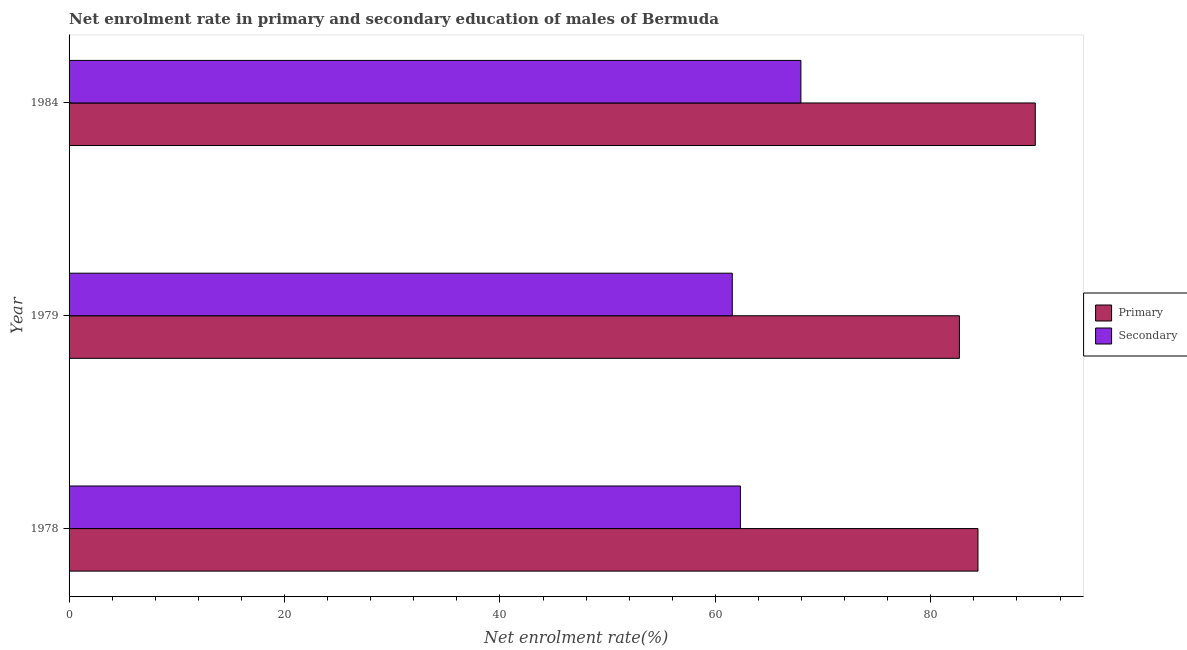How many different coloured bars are there?
Your answer should be compact. 2. Are the number of bars per tick equal to the number of legend labels?
Your answer should be very brief. Yes. How many bars are there on the 1st tick from the bottom?
Your answer should be compact. 2. What is the label of the 2nd group of bars from the top?
Provide a succinct answer. 1979. In how many cases, is the number of bars for a given year not equal to the number of legend labels?
Your answer should be very brief. 0. What is the enrollment rate in secondary education in 1984?
Your response must be concise. 67.95. Across all years, what is the maximum enrollment rate in primary education?
Give a very brief answer. 89.7. Across all years, what is the minimum enrollment rate in secondary education?
Keep it short and to the point. 61.57. In which year was the enrollment rate in primary education minimum?
Give a very brief answer. 1979. What is the total enrollment rate in primary education in the graph?
Offer a very short reply. 256.75. What is the difference between the enrollment rate in secondary education in 1978 and that in 1984?
Keep it short and to the point. -5.62. What is the difference between the enrollment rate in secondary education in 1979 and the enrollment rate in primary education in 1978?
Give a very brief answer. -22.81. What is the average enrollment rate in primary education per year?
Ensure brevity in your answer.  85.58. In the year 1978, what is the difference between the enrollment rate in secondary education and enrollment rate in primary education?
Ensure brevity in your answer.  -22.06. In how many years, is the enrollment rate in secondary education greater than 56 %?
Make the answer very short. 3. What is the ratio of the enrollment rate in secondary education in 1978 to that in 1984?
Offer a very short reply. 0.92. What is the difference between the highest and the second highest enrollment rate in primary education?
Your answer should be very brief. 5.32. What is the difference between the highest and the lowest enrollment rate in secondary education?
Ensure brevity in your answer.  6.37. What does the 1st bar from the top in 1978 represents?
Provide a succinct answer. Secondary. What does the 2nd bar from the bottom in 1984 represents?
Keep it short and to the point. Secondary. Are all the bars in the graph horizontal?
Your response must be concise. Yes. How many years are there in the graph?
Your response must be concise. 3. Are the values on the major ticks of X-axis written in scientific E-notation?
Your response must be concise. No. Where does the legend appear in the graph?
Ensure brevity in your answer.  Center right. How many legend labels are there?
Your answer should be compact. 2. How are the legend labels stacked?
Give a very brief answer. Vertical. What is the title of the graph?
Ensure brevity in your answer.  Net enrolment rate in primary and secondary education of males of Bermuda. What is the label or title of the X-axis?
Give a very brief answer. Net enrolment rate(%). What is the Net enrolment rate(%) in Primary in 1978?
Your response must be concise. 84.38. What is the Net enrolment rate(%) in Secondary in 1978?
Offer a very short reply. 62.33. What is the Net enrolment rate(%) in Primary in 1979?
Offer a terse response. 82.66. What is the Net enrolment rate(%) in Secondary in 1979?
Keep it short and to the point. 61.57. What is the Net enrolment rate(%) of Primary in 1984?
Make the answer very short. 89.7. What is the Net enrolment rate(%) in Secondary in 1984?
Provide a succinct answer. 67.95. Across all years, what is the maximum Net enrolment rate(%) in Primary?
Your answer should be compact. 89.7. Across all years, what is the maximum Net enrolment rate(%) in Secondary?
Ensure brevity in your answer.  67.95. Across all years, what is the minimum Net enrolment rate(%) in Primary?
Your answer should be compact. 82.66. Across all years, what is the minimum Net enrolment rate(%) of Secondary?
Offer a very short reply. 61.57. What is the total Net enrolment rate(%) in Primary in the graph?
Offer a very short reply. 256.75. What is the total Net enrolment rate(%) in Secondary in the graph?
Give a very brief answer. 191.85. What is the difference between the Net enrolment rate(%) in Primary in 1978 and that in 1979?
Your answer should be very brief. 1.72. What is the difference between the Net enrolment rate(%) in Secondary in 1978 and that in 1979?
Offer a terse response. 0.75. What is the difference between the Net enrolment rate(%) of Primary in 1978 and that in 1984?
Provide a short and direct response. -5.32. What is the difference between the Net enrolment rate(%) of Secondary in 1978 and that in 1984?
Your response must be concise. -5.62. What is the difference between the Net enrolment rate(%) of Primary in 1979 and that in 1984?
Give a very brief answer. -7.04. What is the difference between the Net enrolment rate(%) of Secondary in 1979 and that in 1984?
Provide a short and direct response. -6.37. What is the difference between the Net enrolment rate(%) in Primary in 1978 and the Net enrolment rate(%) in Secondary in 1979?
Provide a succinct answer. 22.81. What is the difference between the Net enrolment rate(%) of Primary in 1978 and the Net enrolment rate(%) of Secondary in 1984?
Provide a short and direct response. 16.44. What is the difference between the Net enrolment rate(%) in Primary in 1979 and the Net enrolment rate(%) in Secondary in 1984?
Ensure brevity in your answer.  14.72. What is the average Net enrolment rate(%) in Primary per year?
Provide a short and direct response. 85.58. What is the average Net enrolment rate(%) in Secondary per year?
Make the answer very short. 63.95. In the year 1978, what is the difference between the Net enrolment rate(%) in Primary and Net enrolment rate(%) in Secondary?
Give a very brief answer. 22.06. In the year 1979, what is the difference between the Net enrolment rate(%) in Primary and Net enrolment rate(%) in Secondary?
Offer a terse response. 21.09. In the year 1984, what is the difference between the Net enrolment rate(%) in Primary and Net enrolment rate(%) in Secondary?
Offer a terse response. 21.76. What is the ratio of the Net enrolment rate(%) of Primary in 1978 to that in 1979?
Ensure brevity in your answer.  1.02. What is the ratio of the Net enrolment rate(%) of Secondary in 1978 to that in 1979?
Offer a terse response. 1.01. What is the ratio of the Net enrolment rate(%) in Primary in 1978 to that in 1984?
Ensure brevity in your answer.  0.94. What is the ratio of the Net enrolment rate(%) in Secondary in 1978 to that in 1984?
Ensure brevity in your answer.  0.92. What is the ratio of the Net enrolment rate(%) in Primary in 1979 to that in 1984?
Give a very brief answer. 0.92. What is the ratio of the Net enrolment rate(%) in Secondary in 1979 to that in 1984?
Your answer should be compact. 0.91. What is the difference between the highest and the second highest Net enrolment rate(%) of Primary?
Offer a terse response. 5.32. What is the difference between the highest and the second highest Net enrolment rate(%) in Secondary?
Offer a terse response. 5.62. What is the difference between the highest and the lowest Net enrolment rate(%) of Primary?
Your answer should be compact. 7.04. What is the difference between the highest and the lowest Net enrolment rate(%) in Secondary?
Provide a succinct answer. 6.37. 